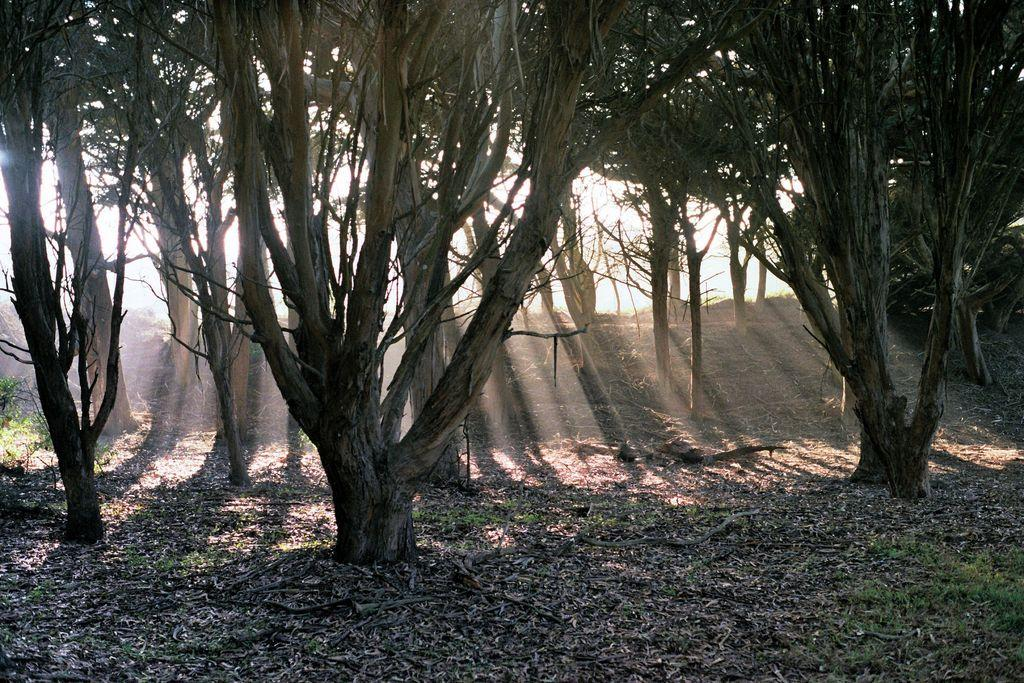What type of vegetation can be seen in the image? There are trees, plants, and grass visible in the image. What is on the ground in the image? There are leaves on the ground in the image. What can be seen between the trees in the image? Sun rays are present between the trees in the image. What is the cook preparing for the person with the strongest desire in the image? There is no cook or person with a desire present in the image; it features trees, plants, grass, leaves, and sun rays. Is there a fire visible in the image? No, there is no fire visible in the image. 